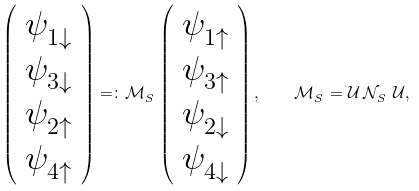<formula> <loc_0><loc_0><loc_500><loc_500>\left ( \begin{array} { c } \psi ^ { \ } _ { 1 \downarrow } \\ \psi ^ { \ } _ { 3 \downarrow } \\ \psi ^ { \ } _ { 2 \uparrow } \\ \psi ^ { \ } _ { 4 \uparrow } \\ \end{array} \right ) = \colon \mathcal { M } ^ { \ } _ { S } \left ( \begin{array} { c } \psi ^ { \ } _ { 1 \uparrow } \\ \psi ^ { \ } _ { 3 \uparrow } \\ \psi ^ { \ } _ { 2 \downarrow } \\ \psi ^ { \ } _ { 4 \downarrow } \\ \end{array} \right ) , \quad \mathcal { M } ^ { \ } _ { S } = \mathcal { U } \, \mathcal { N } ^ { \ } _ { S } \, \mathcal { U } ,</formula> 